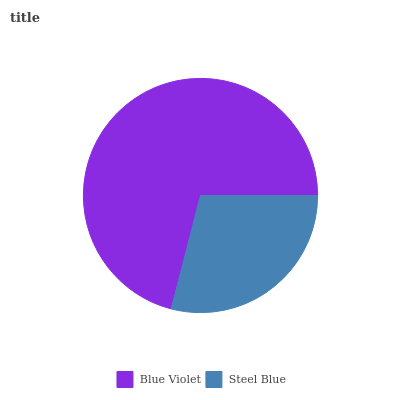Is Steel Blue the minimum?
Answer yes or no. Yes. Is Blue Violet the maximum?
Answer yes or no. Yes. Is Steel Blue the maximum?
Answer yes or no. No. Is Blue Violet greater than Steel Blue?
Answer yes or no. Yes. Is Steel Blue less than Blue Violet?
Answer yes or no. Yes. Is Steel Blue greater than Blue Violet?
Answer yes or no. No. Is Blue Violet less than Steel Blue?
Answer yes or no. No. Is Blue Violet the high median?
Answer yes or no. Yes. Is Steel Blue the low median?
Answer yes or no. Yes. Is Steel Blue the high median?
Answer yes or no. No. Is Blue Violet the low median?
Answer yes or no. No. 